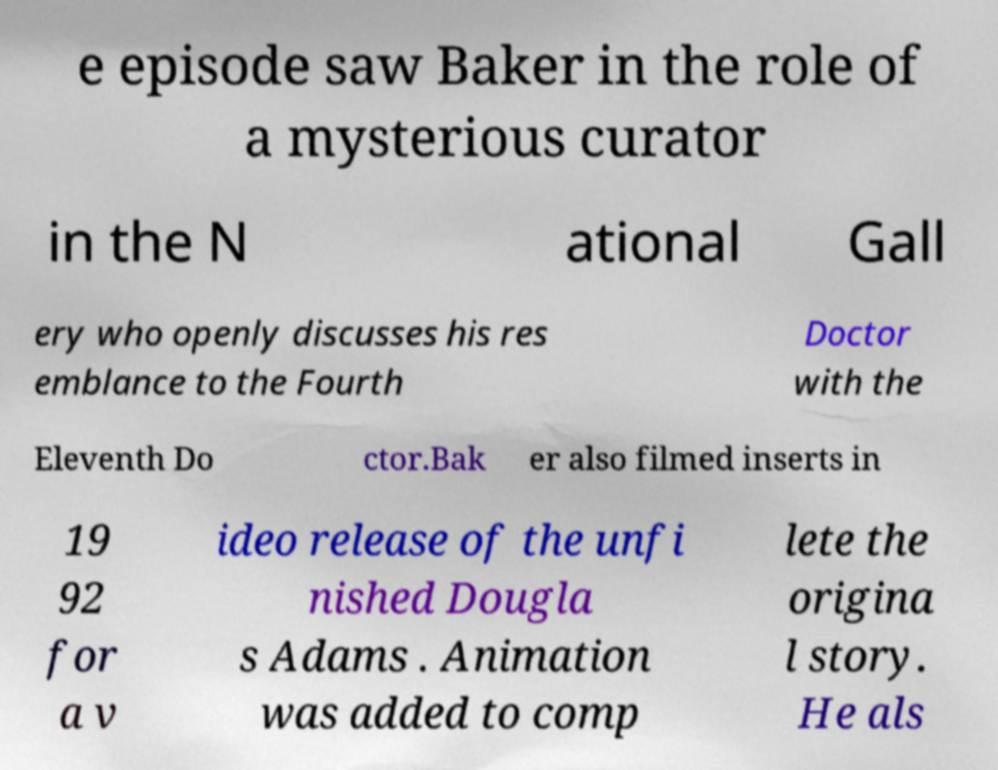Could you assist in decoding the text presented in this image and type it out clearly? e episode saw Baker in the role of a mysterious curator in the N ational Gall ery who openly discusses his res emblance to the Fourth Doctor with the Eleventh Do ctor.Bak er also filmed inserts in 19 92 for a v ideo release of the unfi nished Dougla s Adams . Animation was added to comp lete the origina l story. He als 